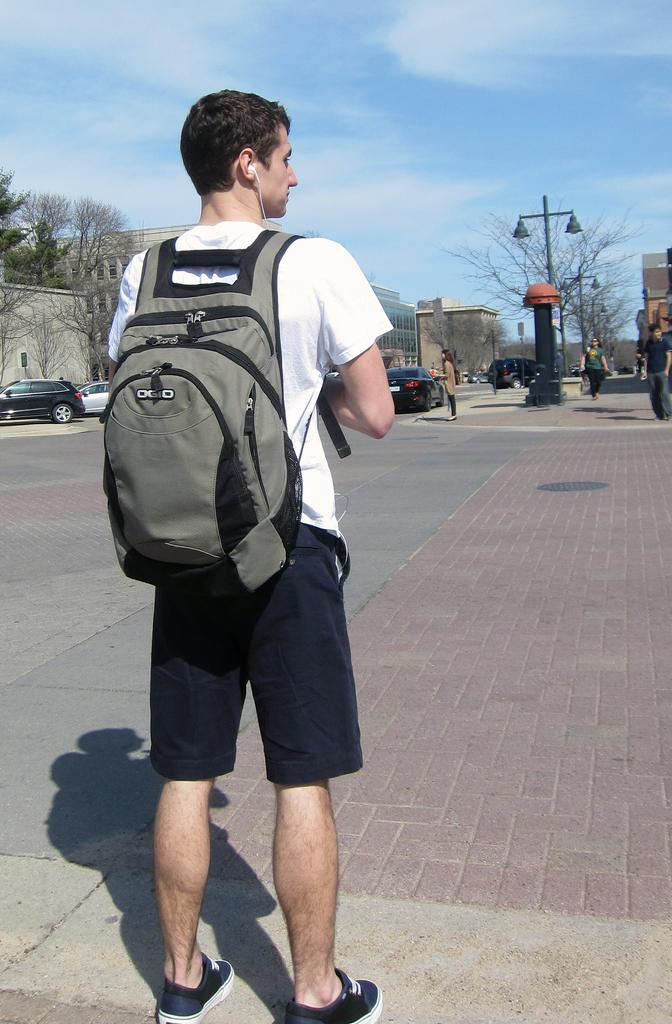What is the main subject of the image? There is a person standing in the image. Can you describe what the person is wearing? The person is wearing a bag. What else can be seen in the distance in the image? There are other people in the distance. What type of transportation is visible in the image? Vehicles are visible on the road. What structures are present in the image? There are buildings in the image. What type of natural elements can be seen in the image? Trees are present in the image. What part of the environment is visible in the image? The sky is visible in the image. What object with a light source is present in the image? There is a pole with a light in the image. How much salt is on the person's shoes in the image? There is no salt visible on the person's shoes in the image. What type of rod can be seen in the person's hand in the image? There is no rod visible in the person's hand in the image. 